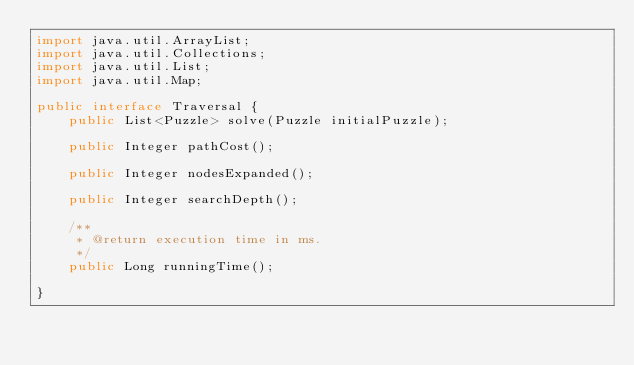Convert code to text. <code><loc_0><loc_0><loc_500><loc_500><_Java_>import java.util.ArrayList;
import java.util.Collections;
import java.util.List;
import java.util.Map;

public interface Traversal {
    public List<Puzzle> solve(Puzzle initialPuzzle);

    public Integer pathCost();

    public Integer nodesExpanded();

    public Integer searchDepth();

    /**
     * @return execution time in ms.
     */
    public Long runningTime();

}
</code> 